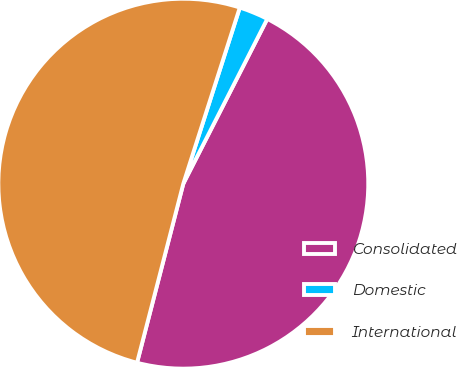Convert chart to OTSL. <chart><loc_0><loc_0><loc_500><loc_500><pie_chart><fcel>Consolidated<fcel>Domestic<fcel>International<nl><fcel>46.52%<fcel>2.56%<fcel>50.91%<nl></chart> 